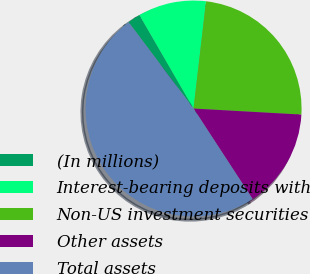<chart> <loc_0><loc_0><loc_500><loc_500><pie_chart><fcel>(In millions)<fcel>Interest-bearing deposits with<fcel>Non-US investment securities<fcel>Other assets<fcel>Total assets<nl><fcel>1.91%<fcel>10.2%<fcel>24.04%<fcel>14.91%<fcel>48.94%<nl></chart> 